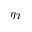Convert formula to latex. <formula><loc_0><loc_0><loc_500><loc_500>\eta _ { T }</formula> 